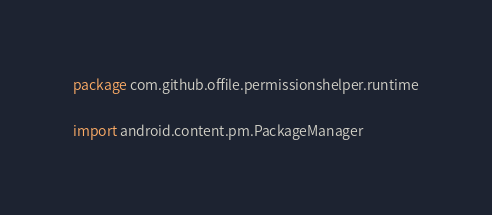<code> <loc_0><loc_0><loc_500><loc_500><_Kotlin_>package com.github.offile.permissionshelper.runtime

import android.content.pm.PackageManager</code> 